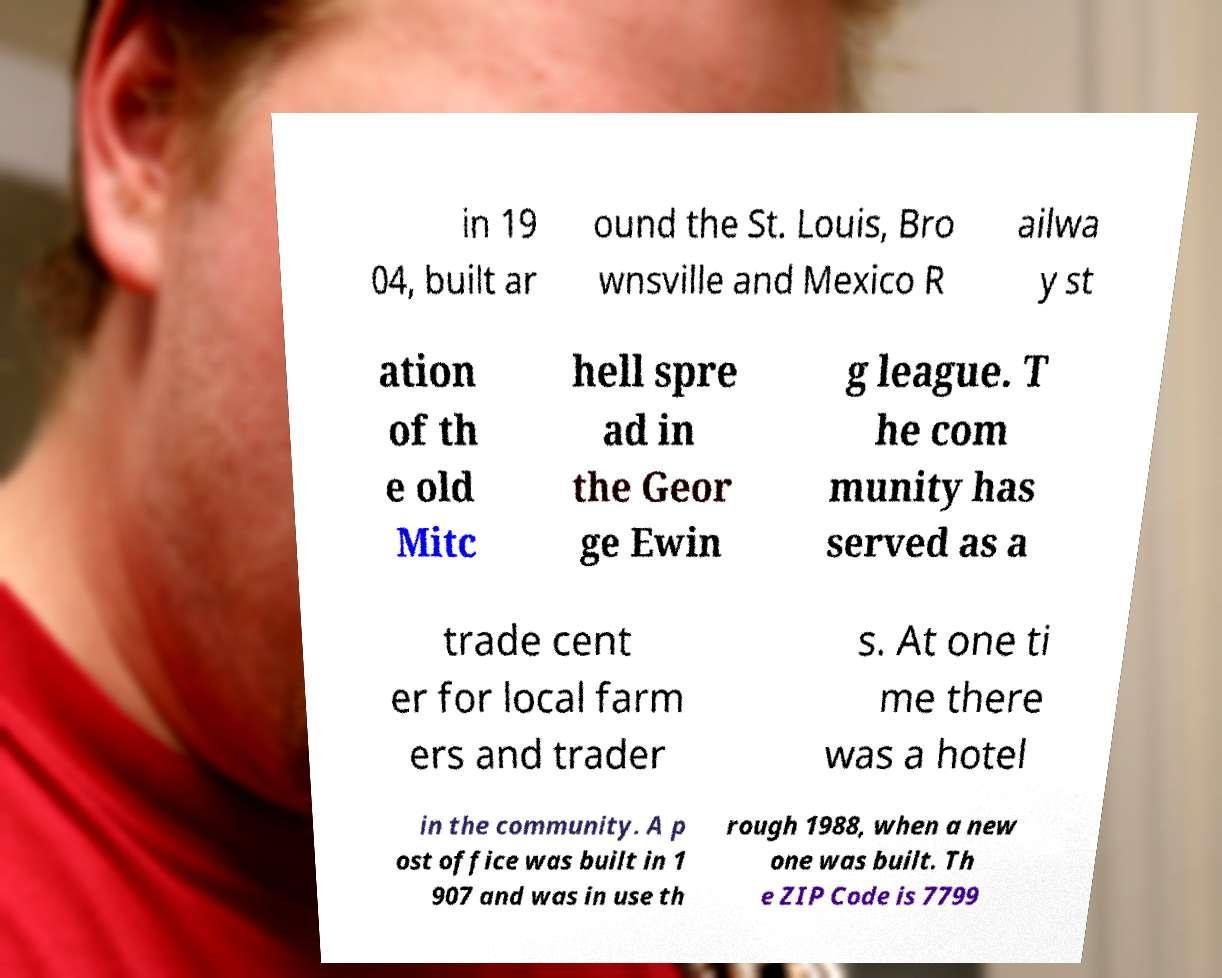What messages or text are displayed in this image? I need them in a readable, typed format. in 19 04, built ar ound the St. Louis, Bro wnsville and Mexico R ailwa y st ation of th e old Mitc hell spre ad in the Geor ge Ewin g league. T he com munity has served as a trade cent er for local farm ers and trader s. At one ti me there was a hotel in the community. A p ost office was built in 1 907 and was in use th rough 1988, when a new one was built. Th e ZIP Code is 7799 